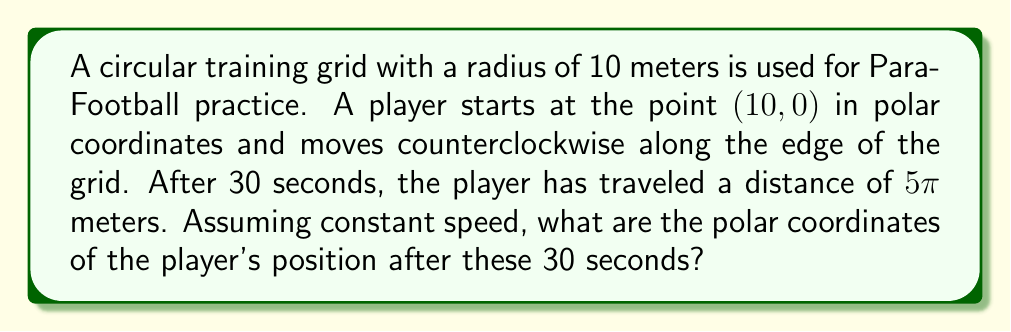Teach me how to tackle this problem. To solve this problem, we need to follow these steps:

1) First, let's recall that in polar coordinates, a point is represented as $(r, \theta)$, where $r$ is the distance from the origin and $\theta$ is the angle from the positive x-axis.

2) The player starts at $(10, 0)$, which means they are on the edge of the circle (radius = 10 meters) at an angle of 0 radians.

3) The distance traveled is $5\pi$ meters. To find the angle this corresponds to, we can use the formula for arc length:

   $s = r\theta$

   Where $s$ is the arc length, $r$ is the radius, and $\theta$ is the angle in radians.

4) Substituting our known values:

   $5\pi = 10\theta$

5) Solving for $\theta$:

   $\theta = \frac{5\pi}{10} = \frac{\pi}{2}$ radians

6) This means the player has moved $\frac{\pi}{2}$ radians counterclockwise from their starting position.

7) The new position in polar coordinates will have the same $r$ value (as the player stays on the edge of the circle) and a $\theta$ value increased by $\frac{\pi}{2}$:

   $r = 10$
   $\theta = 0 + \frac{\pi}{2} = \frac{\pi}{2}$

Therefore, the new position in polar coordinates is $(10, \frac{\pi}{2})$.
Answer: $(10, \frac{\pi}{2})$ 